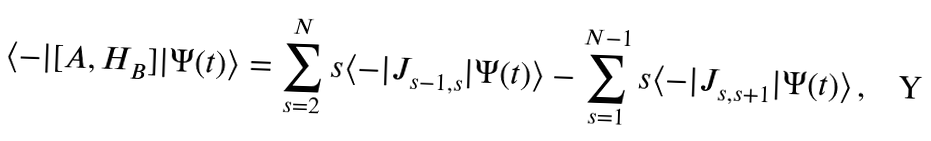<formula> <loc_0><loc_0><loc_500><loc_500>\langle - | [ A , H _ { B } ] | \Psi ( t ) \rangle = \sum _ { s = 2 } ^ { N } s \langle - | { J } _ { s - 1 , s } | \Psi ( t ) \rangle - \sum _ { s = 1 } ^ { N - 1 } s \langle - | { J } _ { s , s + 1 } | \Psi ( t ) \rangle \, ,</formula> 